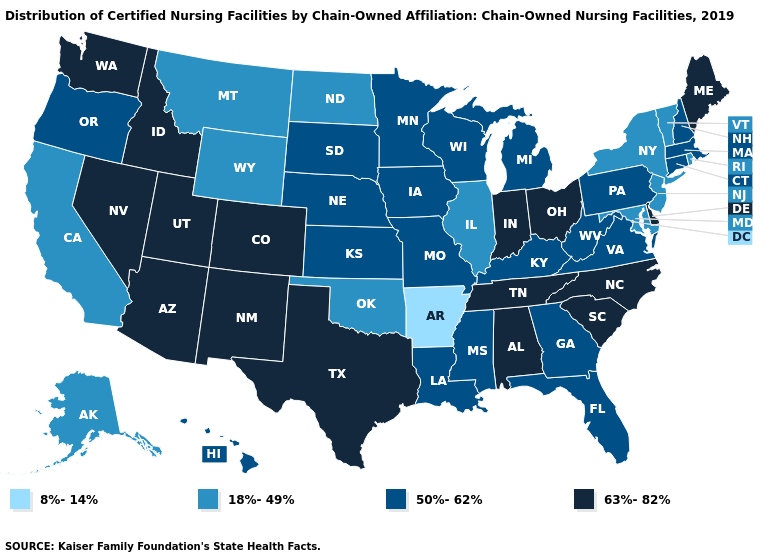What is the value of Kentucky?
Give a very brief answer. 50%-62%. Which states hav the highest value in the South?
Concise answer only. Alabama, Delaware, North Carolina, South Carolina, Tennessee, Texas. What is the value of Delaware?
Be succinct. 63%-82%. Name the states that have a value in the range 63%-82%?
Quick response, please. Alabama, Arizona, Colorado, Delaware, Idaho, Indiana, Maine, Nevada, New Mexico, North Carolina, Ohio, South Carolina, Tennessee, Texas, Utah, Washington. Does Nebraska have a lower value than Arkansas?
Give a very brief answer. No. Does the first symbol in the legend represent the smallest category?
Answer briefly. Yes. What is the lowest value in the MidWest?
Write a very short answer. 18%-49%. Does New Jersey have the lowest value in the Northeast?
Give a very brief answer. Yes. Does Washington have the highest value in the USA?
Give a very brief answer. Yes. Does the map have missing data?
Answer briefly. No. What is the highest value in the USA?
Concise answer only. 63%-82%. Does Arkansas have the lowest value in the USA?
Write a very short answer. Yes. Does Indiana have a lower value than Ohio?
Keep it brief. No. Which states have the highest value in the USA?
Keep it brief. Alabama, Arizona, Colorado, Delaware, Idaho, Indiana, Maine, Nevada, New Mexico, North Carolina, Ohio, South Carolina, Tennessee, Texas, Utah, Washington. How many symbols are there in the legend?
Be succinct. 4. 